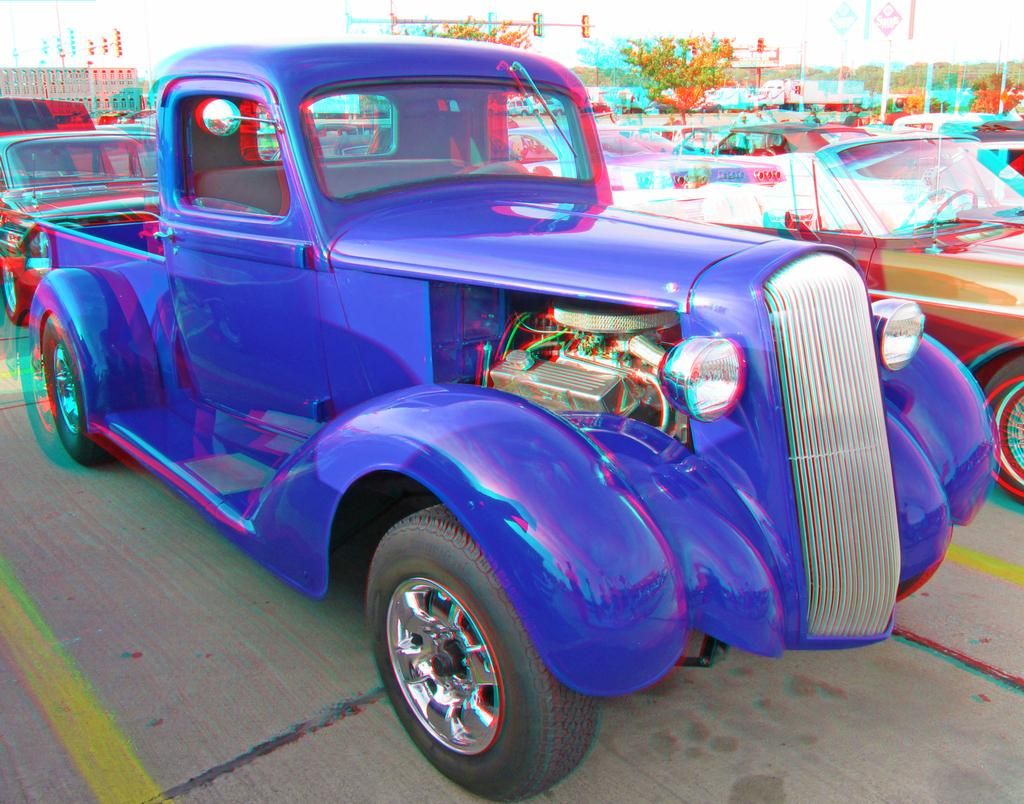What can be seen in the image in terms of vehicles? There are many cars parked in one place in the image. What type of natural elements can be seen in the background of the image? There are trees visible in the background of the image. What type of man-made structures can be seen in the background of the image? There are buildings visible in the background of the image. What type of pipe is visible in the image? There is no pipe present in the image. What action are the birds performing in the image? There are no birds present in the image. 